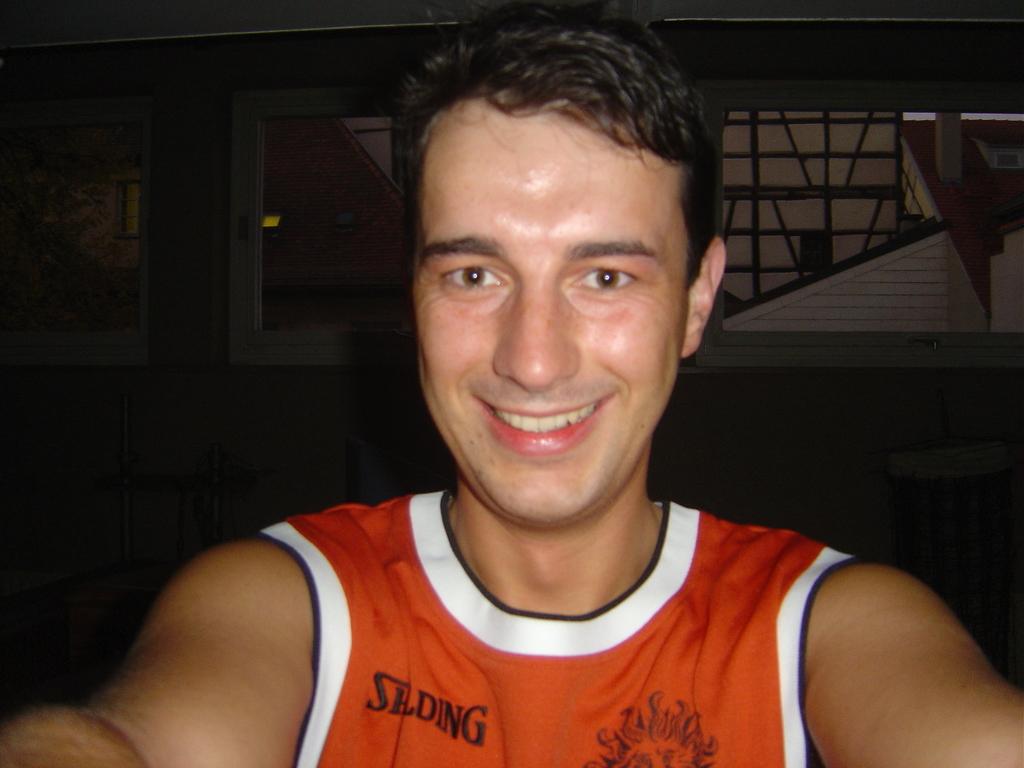What is on his hersey?
Provide a succinct answer. Spalding. 